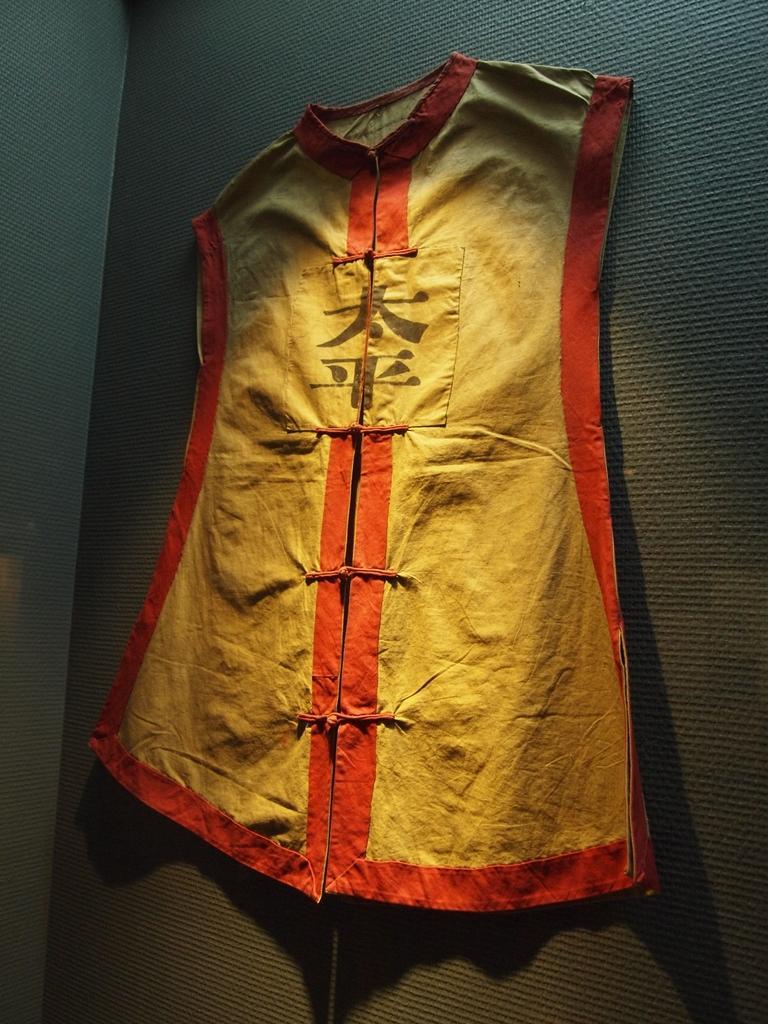Can you describe this image briefly? In this image we can see a jacket attached to the wall. 